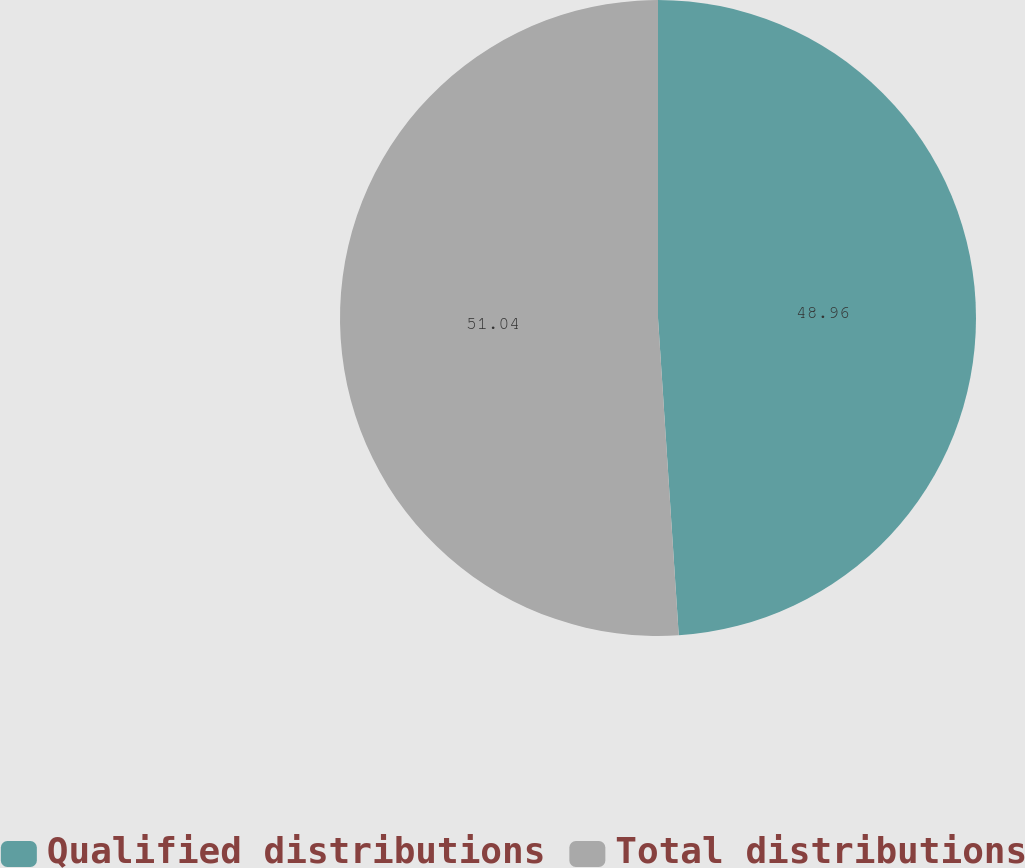<chart> <loc_0><loc_0><loc_500><loc_500><pie_chart><fcel>Qualified distributions<fcel>Total distributions<nl><fcel>48.96%<fcel>51.04%<nl></chart> 